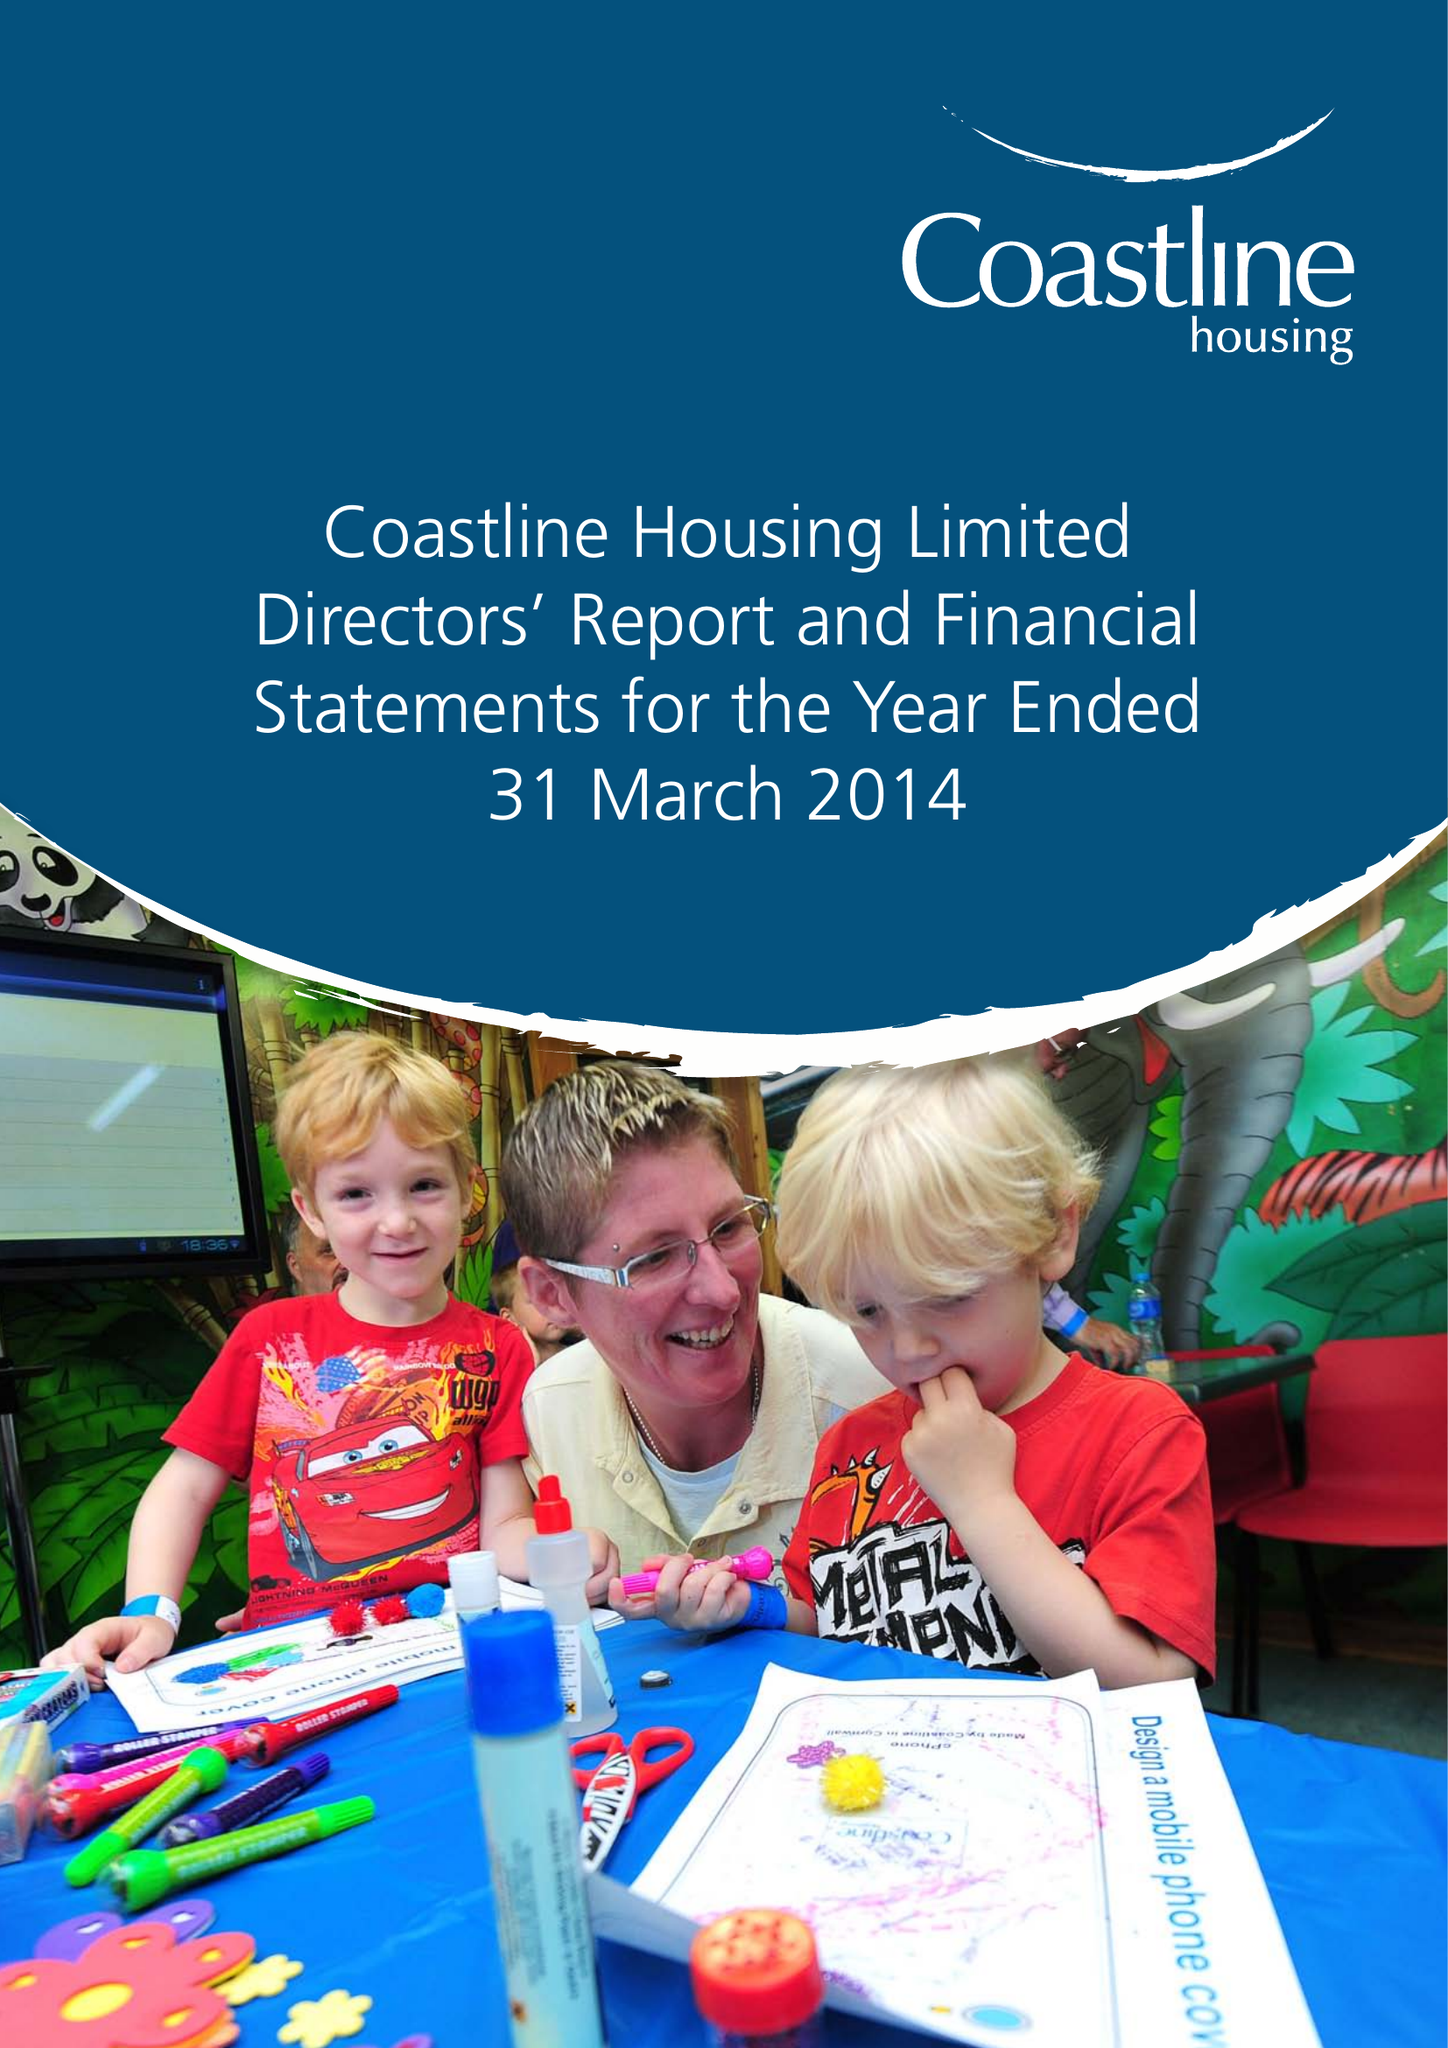What is the value for the address__post_town?
Answer the question using a single word or phrase. REDRUTH 